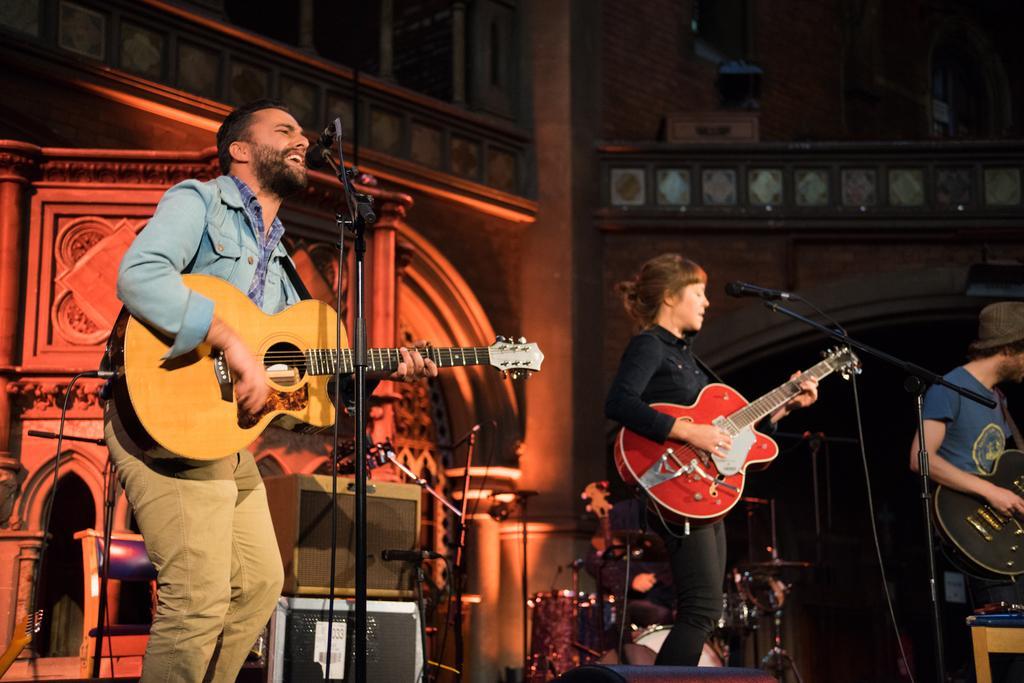Could you give a brief overview of what you see in this image? A man with a blue color shirt and cream color pant playing a guitar in his hand and singing a song in the microphone and at the right side of him there are some speakers and there is bass drum,crash cymbal and there is a cymbal stand and drums and there is a woman who is playing a guitar and singing a song in the microphone and there is another person who is wearing brown color hat and a blue color shirt and playing a guitar. 